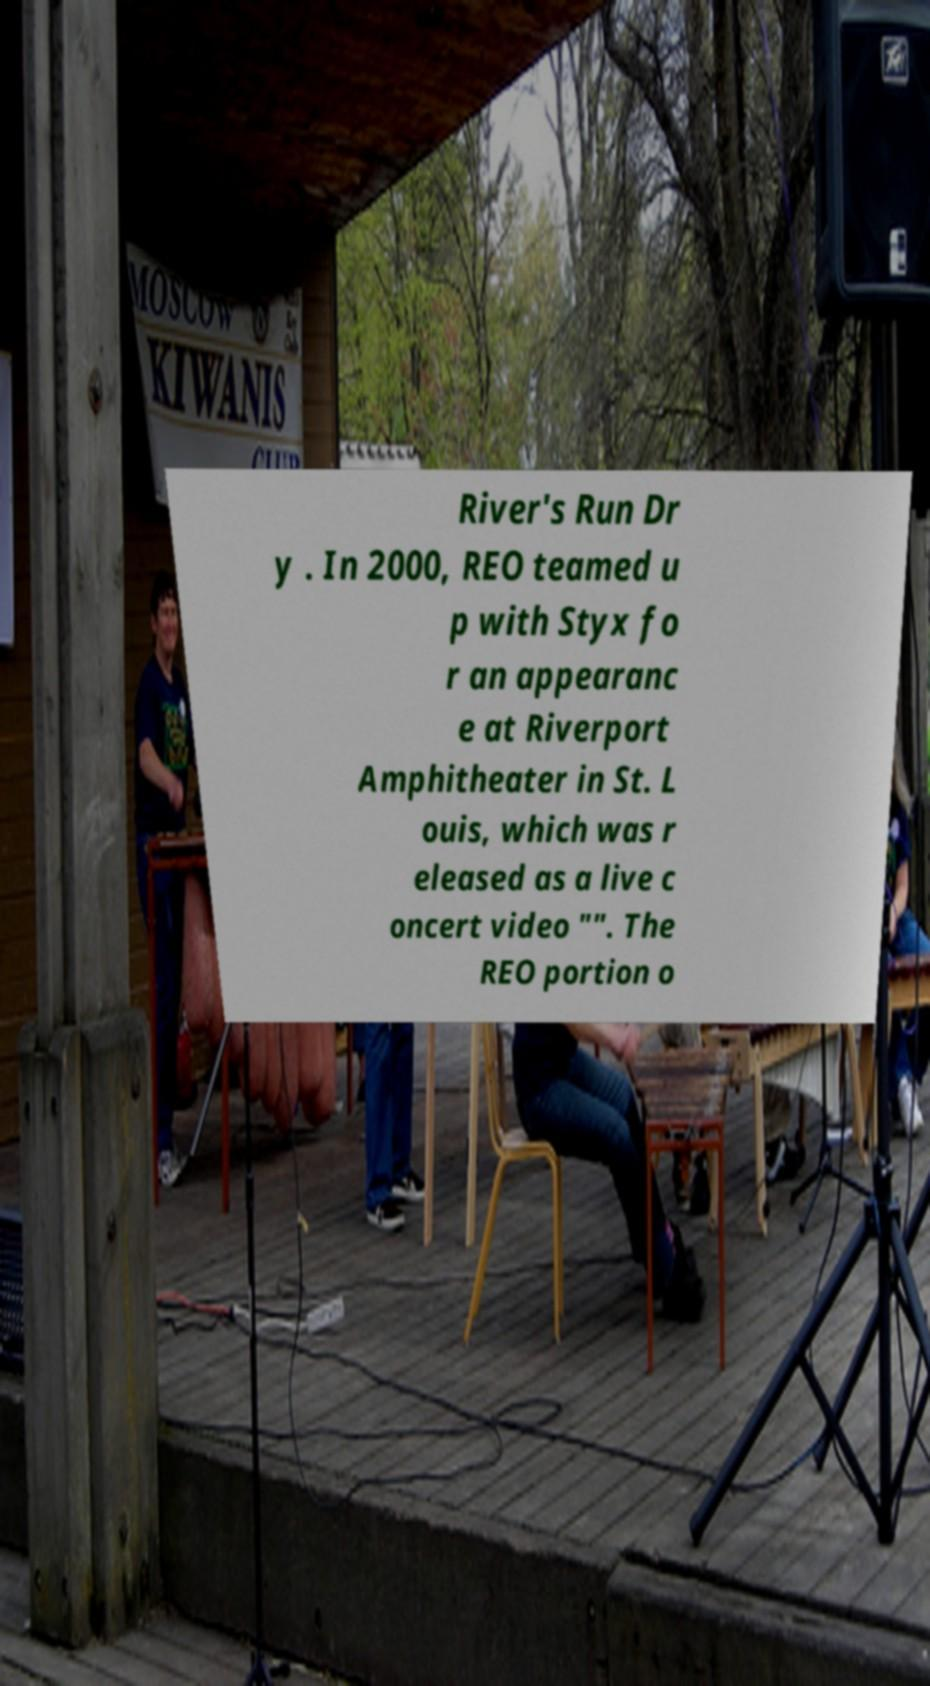Please identify and transcribe the text found in this image. River's Run Dr y . In 2000, REO teamed u p with Styx fo r an appearanc e at Riverport Amphitheater in St. L ouis, which was r eleased as a live c oncert video "". The REO portion o 